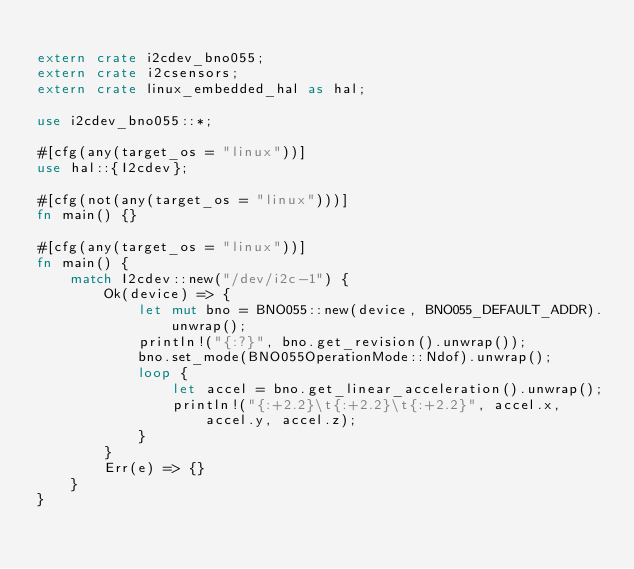Convert code to text. <code><loc_0><loc_0><loc_500><loc_500><_Rust_>
extern crate i2cdev_bno055;
extern crate i2csensors;
extern crate linux_embedded_hal as hal;

use i2cdev_bno055::*;

#[cfg(any(target_os = "linux"))]
use hal::{I2cdev};

#[cfg(not(any(target_os = "linux")))]
fn main() {}

#[cfg(any(target_os = "linux"))]
fn main() {
    match I2cdev::new("/dev/i2c-1") {
        Ok(device) => {
            let mut bno = BNO055::new(device, BNO055_DEFAULT_ADDR).unwrap();
            println!("{:?}", bno.get_revision().unwrap());
            bno.set_mode(BNO055OperationMode::Ndof).unwrap();
            loop {
                let accel = bno.get_linear_acceleration().unwrap();
                println!("{:+2.2}\t{:+2.2}\t{:+2.2}", accel.x, accel.y, accel.z);
            }
        }
        Err(e) => {}
    }
}
</code> 